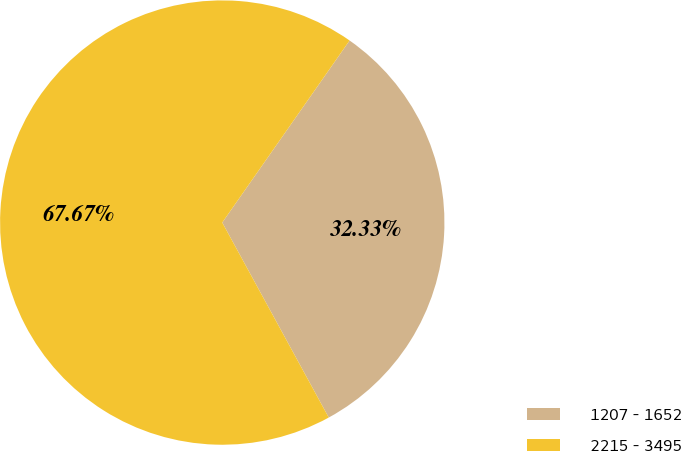<chart> <loc_0><loc_0><loc_500><loc_500><pie_chart><fcel>1207 - 1652<fcel>2215 - 3495<nl><fcel>32.33%<fcel>67.67%<nl></chart> 